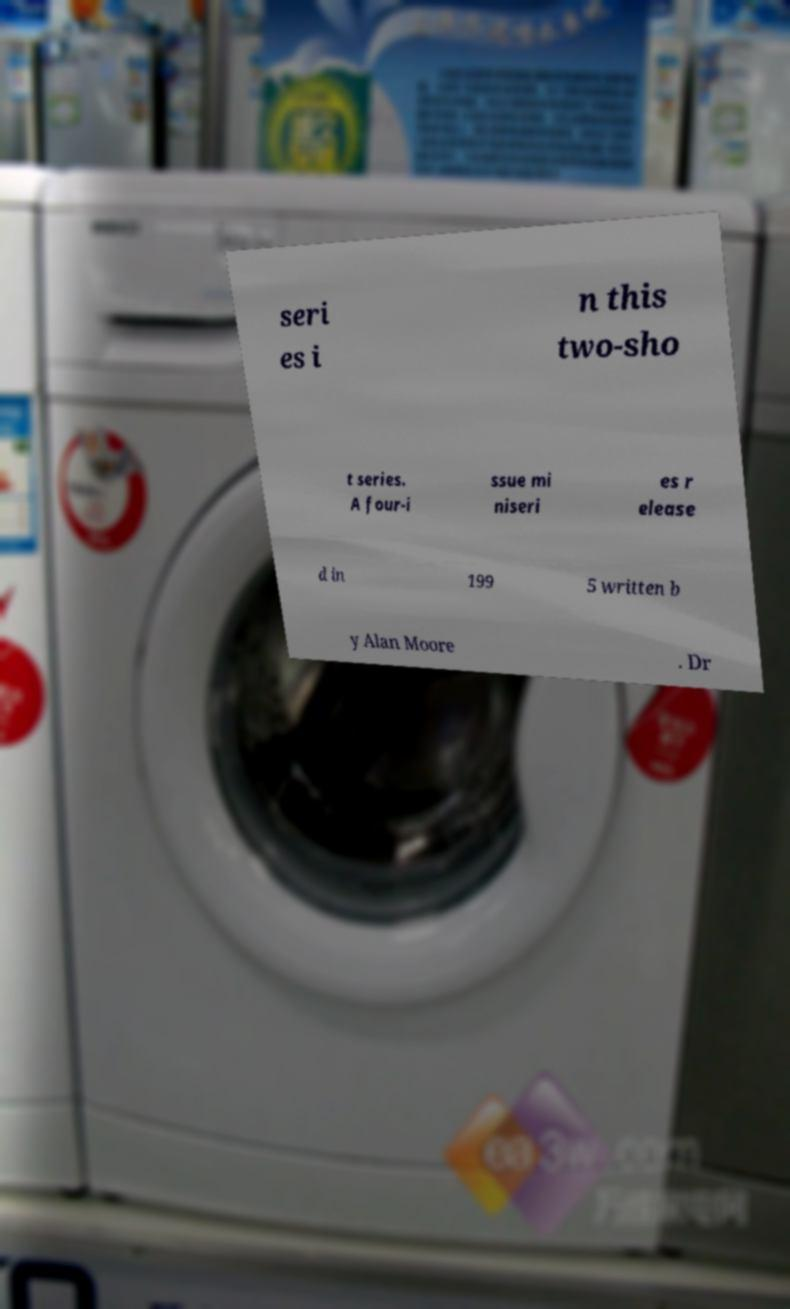Please identify and transcribe the text found in this image. seri es i n this two-sho t series. A four-i ssue mi niseri es r elease d in 199 5 written b y Alan Moore . Dr 